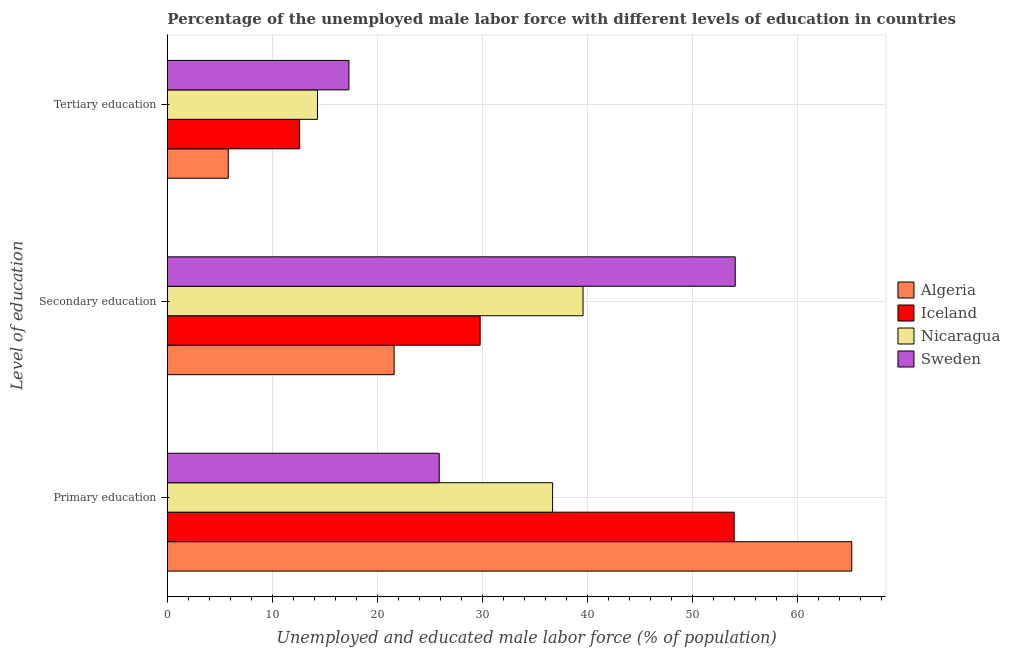Are the number of bars on each tick of the Y-axis equal?
Your response must be concise. Yes. What is the label of the 2nd group of bars from the top?
Provide a succinct answer. Secondary education. What is the percentage of male labor force who received tertiary education in Sweden?
Your response must be concise. 17.3. Across all countries, what is the maximum percentage of male labor force who received tertiary education?
Offer a very short reply. 17.3. Across all countries, what is the minimum percentage of male labor force who received secondary education?
Provide a succinct answer. 21.6. In which country was the percentage of male labor force who received tertiary education minimum?
Your response must be concise. Algeria. What is the total percentage of male labor force who received secondary education in the graph?
Your answer should be compact. 145.1. What is the difference between the percentage of male labor force who received primary education in Algeria and that in Sweden?
Provide a short and direct response. 39.3. What is the difference between the percentage of male labor force who received primary education in Nicaragua and the percentage of male labor force who received secondary education in Sweden?
Provide a short and direct response. -17.4. What is the average percentage of male labor force who received primary education per country?
Your answer should be very brief. 45.45. What is the difference between the percentage of male labor force who received tertiary education and percentage of male labor force who received primary education in Algeria?
Your answer should be compact. -59.4. What is the ratio of the percentage of male labor force who received primary education in Sweden to that in Algeria?
Provide a short and direct response. 0.4. Is the percentage of male labor force who received tertiary education in Algeria less than that in Iceland?
Your answer should be very brief. Yes. Is the difference between the percentage of male labor force who received tertiary education in Algeria and Nicaragua greater than the difference between the percentage of male labor force who received secondary education in Algeria and Nicaragua?
Ensure brevity in your answer.  Yes. What is the difference between the highest and the second highest percentage of male labor force who received secondary education?
Provide a short and direct response. 14.5. What is the difference between the highest and the lowest percentage of male labor force who received secondary education?
Your answer should be very brief. 32.5. In how many countries, is the percentage of male labor force who received tertiary education greater than the average percentage of male labor force who received tertiary education taken over all countries?
Your answer should be very brief. 3. What does the 2nd bar from the top in Primary education represents?
Your response must be concise. Nicaragua. What does the 3rd bar from the bottom in Tertiary education represents?
Provide a short and direct response. Nicaragua. How many bars are there?
Give a very brief answer. 12. Are the values on the major ticks of X-axis written in scientific E-notation?
Provide a short and direct response. No. Does the graph contain any zero values?
Make the answer very short. No. Does the graph contain grids?
Your answer should be compact. Yes. Where does the legend appear in the graph?
Your response must be concise. Center right. How are the legend labels stacked?
Your answer should be very brief. Vertical. What is the title of the graph?
Your answer should be very brief. Percentage of the unemployed male labor force with different levels of education in countries. What is the label or title of the X-axis?
Your response must be concise. Unemployed and educated male labor force (% of population). What is the label or title of the Y-axis?
Keep it short and to the point. Level of education. What is the Unemployed and educated male labor force (% of population) of Algeria in Primary education?
Keep it short and to the point. 65.2. What is the Unemployed and educated male labor force (% of population) in Iceland in Primary education?
Keep it short and to the point. 54. What is the Unemployed and educated male labor force (% of population) in Nicaragua in Primary education?
Provide a short and direct response. 36.7. What is the Unemployed and educated male labor force (% of population) in Sweden in Primary education?
Provide a succinct answer. 25.9. What is the Unemployed and educated male labor force (% of population) in Algeria in Secondary education?
Provide a short and direct response. 21.6. What is the Unemployed and educated male labor force (% of population) in Iceland in Secondary education?
Give a very brief answer. 29.8. What is the Unemployed and educated male labor force (% of population) in Nicaragua in Secondary education?
Give a very brief answer. 39.6. What is the Unemployed and educated male labor force (% of population) in Sweden in Secondary education?
Offer a very short reply. 54.1. What is the Unemployed and educated male labor force (% of population) in Algeria in Tertiary education?
Your answer should be very brief. 5.8. What is the Unemployed and educated male labor force (% of population) in Iceland in Tertiary education?
Give a very brief answer. 12.6. What is the Unemployed and educated male labor force (% of population) in Nicaragua in Tertiary education?
Offer a terse response. 14.3. What is the Unemployed and educated male labor force (% of population) in Sweden in Tertiary education?
Offer a terse response. 17.3. Across all Level of education, what is the maximum Unemployed and educated male labor force (% of population) of Algeria?
Provide a short and direct response. 65.2. Across all Level of education, what is the maximum Unemployed and educated male labor force (% of population) in Iceland?
Provide a short and direct response. 54. Across all Level of education, what is the maximum Unemployed and educated male labor force (% of population) of Nicaragua?
Give a very brief answer. 39.6. Across all Level of education, what is the maximum Unemployed and educated male labor force (% of population) of Sweden?
Ensure brevity in your answer.  54.1. Across all Level of education, what is the minimum Unemployed and educated male labor force (% of population) of Algeria?
Make the answer very short. 5.8. Across all Level of education, what is the minimum Unemployed and educated male labor force (% of population) of Iceland?
Provide a short and direct response. 12.6. Across all Level of education, what is the minimum Unemployed and educated male labor force (% of population) in Nicaragua?
Make the answer very short. 14.3. Across all Level of education, what is the minimum Unemployed and educated male labor force (% of population) in Sweden?
Make the answer very short. 17.3. What is the total Unemployed and educated male labor force (% of population) in Algeria in the graph?
Your response must be concise. 92.6. What is the total Unemployed and educated male labor force (% of population) of Iceland in the graph?
Give a very brief answer. 96.4. What is the total Unemployed and educated male labor force (% of population) in Nicaragua in the graph?
Give a very brief answer. 90.6. What is the total Unemployed and educated male labor force (% of population) in Sweden in the graph?
Provide a short and direct response. 97.3. What is the difference between the Unemployed and educated male labor force (% of population) of Algeria in Primary education and that in Secondary education?
Your response must be concise. 43.6. What is the difference between the Unemployed and educated male labor force (% of population) in Iceland in Primary education and that in Secondary education?
Give a very brief answer. 24.2. What is the difference between the Unemployed and educated male labor force (% of population) of Sweden in Primary education and that in Secondary education?
Your answer should be compact. -28.2. What is the difference between the Unemployed and educated male labor force (% of population) in Algeria in Primary education and that in Tertiary education?
Your answer should be compact. 59.4. What is the difference between the Unemployed and educated male labor force (% of population) of Iceland in Primary education and that in Tertiary education?
Provide a succinct answer. 41.4. What is the difference between the Unemployed and educated male labor force (% of population) in Nicaragua in Primary education and that in Tertiary education?
Keep it short and to the point. 22.4. What is the difference between the Unemployed and educated male labor force (% of population) in Iceland in Secondary education and that in Tertiary education?
Make the answer very short. 17.2. What is the difference between the Unemployed and educated male labor force (% of population) in Nicaragua in Secondary education and that in Tertiary education?
Your answer should be very brief. 25.3. What is the difference between the Unemployed and educated male labor force (% of population) in Sweden in Secondary education and that in Tertiary education?
Make the answer very short. 36.8. What is the difference between the Unemployed and educated male labor force (% of population) of Algeria in Primary education and the Unemployed and educated male labor force (% of population) of Iceland in Secondary education?
Provide a short and direct response. 35.4. What is the difference between the Unemployed and educated male labor force (% of population) of Algeria in Primary education and the Unemployed and educated male labor force (% of population) of Nicaragua in Secondary education?
Provide a short and direct response. 25.6. What is the difference between the Unemployed and educated male labor force (% of population) in Algeria in Primary education and the Unemployed and educated male labor force (% of population) in Sweden in Secondary education?
Provide a short and direct response. 11.1. What is the difference between the Unemployed and educated male labor force (% of population) in Iceland in Primary education and the Unemployed and educated male labor force (% of population) in Sweden in Secondary education?
Your answer should be very brief. -0.1. What is the difference between the Unemployed and educated male labor force (% of population) of Nicaragua in Primary education and the Unemployed and educated male labor force (% of population) of Sweden in Secondary education?
Keep it short and to the point. -17.4. What is the difference between the Unemployed and educated male labor force (% of population) in Algeria in Primary education and the Unemployed and educated male labor force (% of population) in Iceland in Tertiary education?
Offer a very short reply. 52.6. What is the difference between the Unemployed and educated male labor force (% of population) of Algeria in Primary education and the Unemployed and educated male labor force (% of population) of Nicaragua in Tertiary education?
Keep it short and to the point. 50.9. What is the difference between the Unemployed and educated male labor force (% of population) of Algeria in Primary education and the Unemployed and educated male labor force (% of population) of Sweden in Tertiary education?
Your answer should be compact. 47.9. What is the difference between the Unemployed and educated male labor force (% of population) of Iceland in Primary education and the Unemployed and educated male labor force (% of population) of Nicaragua in Tertiary education?
Your answer should be compact. 39.7. What is the difference between the Unemployed and educated male labor force (% of population) in Iceland in Primary education and the Unemployed and educated male labor force (% of population) in Sweden in Tertiary education?
Offer a very short reply. 36.7. What is the difference between the Unemployed and educated male labor force (% of population) in Algeria in Secondary education and the Unemployed and educated male labor force (% of population) in Iceland in Tertiary education?
Your response must be concise. 9. What is the difference between the Unemployed and educated male labor force (% of population) of Nicaragua in Secondary education and the Unemployed and educated male labor force (% of population) of Sweden in Tertiary education?
Offer a very short reply. 22.3. What is the average Unemployed and educated male labor force (% of population) in Algeria per Level of education?
Make the answer very short. 30.87. What is the average Unemployed and educated male labor force (% of population) in Iceland per Level of education?
Give a very brief answer. 32.13. What is the average Unemployed and educated male labor force (% of population) in Nicaragua per Level of education?
Your response must be concise. 30.2. What is the average Unemployed and educated male labor force (% of population) in Sweden per Level of education?
Your answer should be compact. 32.43. What is the difference between the Unemployed and educated male labor force (% of population) in Algeria and Unemployed and educated male labor force (% of population) in Iceland in Primary education?
Give a very brief answer. 11.2. What is the difference between the Unemployed and educated male labor force (% of population) in Algeria and Unemployed and educated male labor force (% of population) in Sweden in Primary education?
Provide a short and direct response. 39.3. What is the difference between the Unemployed and educated male labor force (% of population) in Iceland and Unemployed and educated male labor force (% of population) in Sweden in Primary education?
Provide a succinct answer. 28.1. What is the difference between the Unemployed and educated male labor force (% of population) in Nicaragua and Unemployed and educated male labor force (% of population) in Sweden in Primary education?
Your answer should be compact. 10.8. What is the difference between the Unemployed and educated male labor force (% of population) in Algeria and Unemployed and educated male labor force (% of population) in Sweden in Secondary education?
Keep it short and to the point. -32.5. What is the difference between the Unemployed and educated male labor force (% of population) in Iceland and Unemployed and educated male labor force (% of population) in Sweden in Secondary education?
Offer a terse response. -24.3. What is the difference between the Unemployed and educated male labor force (% of population) in Algeria and Unemployed and educated male labor force (% of population) in Iceland in Tertiary education?
Offer a terse response. -6.8. What is the difference between the Unemployed and educated male labor force (% of population) of Algeria and Unemployed and educated male labor force (% of population) of Nicaragua in Tertiary education?
Provide a short and direct response. -8.5. What is the difference between the Unemployed and educated male labor force (% of population) of Algeria and Unemployed and educated male labor force (% of population) of Sweden in Tertiary education?
Provide a short and direct response. -11.5. What is the difference between the Unemployed and educated male labor force (% of population) of Iceland and Unemployed and educated male labor force (% of population) of Nicaragua in Tertiary education?
Your response must be concise. -1.7. What is the ratio of the Unemployed and educated male labor force (% of population) of Algeria in Primary education to that in Secondary education?
Make the answer very short. 3.02. What is the ratio of the Unemployed and educated male labor force (% of population) in Iceland in Primary education to that in Secondary education?
Ensure brevity in your answer.  1.81. What is the ratio of the Unemployed and educated male labor force (% of population) of Nicaragua in Primary education to that in Secondary education?
Make the answer very short. 0.93. What is the ratio of the Unemployed and educated male labor force (% of population) in Sweden in Primary education to that in Secondary education?
Keep it short and to the point. 0.48. What is the ratio of the Unemployed and educated male labor force (% of population) in Algeria in Primary education to that in Tertiary education?
Make the answer very short. 11.24. What is the ratio of the Unemployed and educated male labor force (% of population) of Iceland in Primary education to that in Tertiary education?
Keep it short and to the point. 4.29. What is the ratio of the Unemployed and educated male labor force (% of population) in Nicaragua in Primary education to that in Tertiary education?
Provide a short and direct response. 2.57. What is the ratio of the Unemployed and educated male labor force (% of population) of Sweden in Primary education to that in Tertiary education?
Your answer should be very brief. 1.5. What is the ratio of the Unemployed and educated male labor force (% of population) of Algeria in Secondary education to that in Tertiary education?
Offer a very short reply. 3.72. What is the ratio of the Unemployed and educated male labor force (% of population) of Iceland in Secondary education to that in Tertiary education?
Provide a succinct answer. 2.37. What is the ratio of the Unemployed and educated male labor force (% of population) in Nicaragua in Secondary education to that in Tertiary education?
Give a very brief answer. 2.77. What is the ratio of the Unemployed and educated male labor force (% of population) of Sweden in Secondary education to that in Tertiary education?
Give a very brief answer. 3.13. What is the difference between the highest and the second highest Unemployed and educated male labor force (% of population) in Algeria?
Provide a short and direct response. 43.6. What is the difference between the highest and the second highest Unemployed and educated male labor force (% of population) of Iceland?
Ensure brevity in your answer.  24.2. What is the difference between the highest and the second highest Unemployed and educated male labor force (% of population) of Nicaragua?
Give a very brief answer. 2.9. What is the difference between the highest and the second highest Unemployed and educated male labor force (% of population) in Sweden?
Offer a terse response. 28.2. What is the difference between the highest and the lowest Unemployed and educated male labor force (% of population) of Algeria?
Provide a short and direct response. 59.4. What is the difference between the highest and the lowest Unemployed and educated male labor force (% of population) in Iceland?
Provide a short and direct response. 41.4. What is the difference between the highest and the lowest Unemployed and educated male labor force (% of population) in Nicaragua?
Offer a very short reply. 25.3. What is the difference between the highest and the lowest Unemployed and educated male labor force (% of population) in Sweden?
Ensure brevity in your answer.  36.8. 